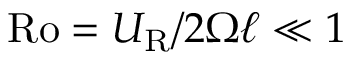<formula> <loc_0><loc_0><loc_500><loc_500>R o = U _ { R } / 2 \Omega \ell \ll 1</formula> 